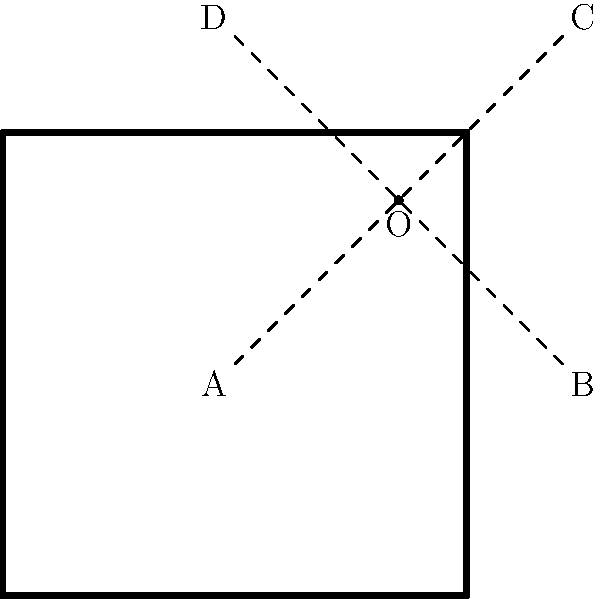Consider the diagram of a square wrestling ring ABCD with center O. How many lines of symmetry does this ring have, and what is the order of its rotational symmetry group? Let's analyze the symmetry of the square wrestling ring step by step:

1. Lines of symmetry:
   a) The square has 4 lines of symmetry:
      - Two diagonals (AC and BD)
      - Two lines passing through the midpoints of opposite sides (vertical and horizontal)

2. Rotational symmetry:
   a) The square can be rotated 90°, 180°, 270°, and 360° (full rotation) about its center O to coincide with itself.
   b) This means it has rotational symmetry of order 4.

3. Symmetry group:
   The symmetry group of a square is known as the dihedral group $D_4$, which includes both reflections and rotations.

4. Order of the rotational symmetry group:
   The rotational symmetry group is a subgroup of $D_4$ that includes only the rotations.
   It has 4 elements: rotations by 0°, 90°, 180°, and 270°.
   Therefore, the order of the rotational symmetry group is 4.

In group theory, this rotational symmetry group is isomorphic to the cyclic group $C_4$.
Answer: 4 lines of symmetry; order 4 